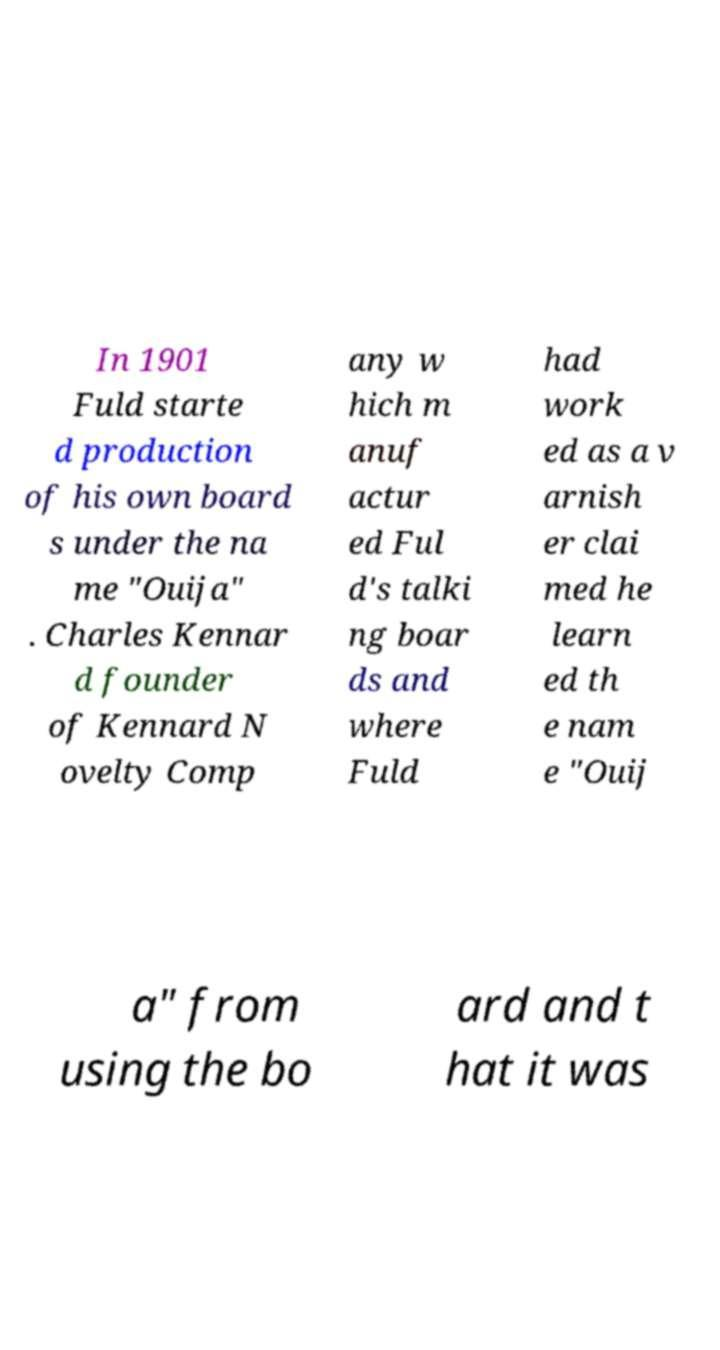There's text embedded in this image that I need extracted. Can you transcribe it verbatim? In 1901 Fuld starte d production of his own board s under the na me "Ouija" . Charles Kennar d founder of Kennard N ovelty Comp any w hich m anuf actur ed Ful d's talki ng boar ds and where Fuld had work ed as a v arnish er clai med he learn ed th e nam e "Ouij a" from using the bo ard and t hat it was 